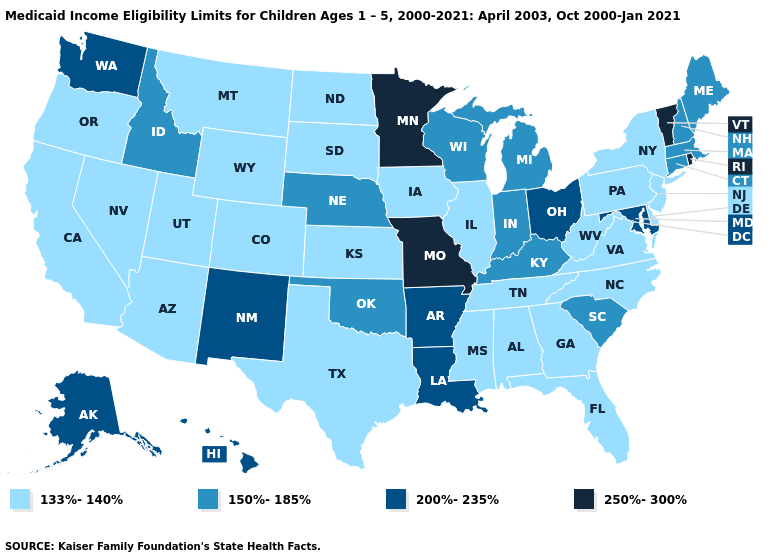Name the states that have a value in the range 133%-140%?
Be succinct. Alabama, Arizona, California, Colorado, Delaware, Florida, Georgia, Illinois, Iowa, Kansas, Mississippi, Montana, Nevada, New Jersey, New York, North Carolina, North Dakota, Oregon, Pennsylvania, South Dakota, Tennessee, Texas, Utah, Virginia, West Virginia, Wyoming. Does the map have missing data?
Short answer required. No. Does Louisiana have the same value as New Hampshire?
Answer briefly. No. What is the value of Ohio?
Give a very brief answer. 200%-235%. What is the value of Minnesota?
Write a very short answer. 250%-300%. What is the value of Montana?
Short answer required. 133%-140%. Which states have the highest value in the USA?
Write a very short answer. Minnesota, Missouri, Rhode Island, Vermont. Does New Hampshire have the highest value in the Northeast?
Quick response, please. No. Does Maryland have the highest value in the South?
Short answer required. Yes. Does New York have the lowest value in the USA?
Answer briefly. Yes. Which states have the lowest value in the USA?
Quick response, please. Alabama, Arizona, California, Colorado, Delaware, Florida, Georgia, Illinois, Iowa, Kansas, Mississippi, Montana, Nevada, New Jersey, New York, North Carolina, North Dakota, Oregon, Pennsylvania, South Dakota, Tennessee, Texas, Utah, Virginia, West Virginia, Wyoming. What is the value of Wisconsin?
Short answer required. 150%-185%. Which states have the lowest value in the West?
Answer briefly. Arizona, California, Colorado, Montana, Nevada, Oregon, Utah, Wyoming. What is the value of Vermont?
Short answer required. 250%-300%. Among the states that border Florida , which have the highest value?
Write a very short answer. Alabama, Georgia. 